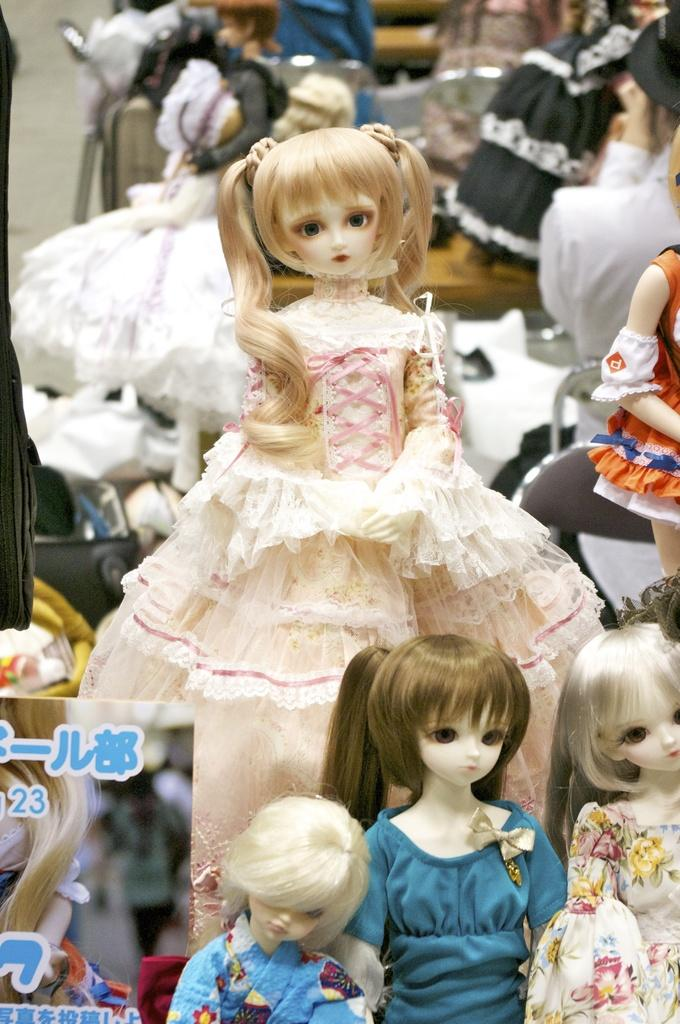What type of objects are in the image? There are dolls and a card in the image. Can you describe any other objects present in the image? There are other unspecified objects in the image. Where is the goose located in the image? There is no goose present in the image. What type of place is depicted in the image? The facts provided do not give any information about the type of place depicted in the image. Are there any bubbles visible in the image? There is no mention of bubbles in the provided facts, so it cannot be determined if any are present in the image. 